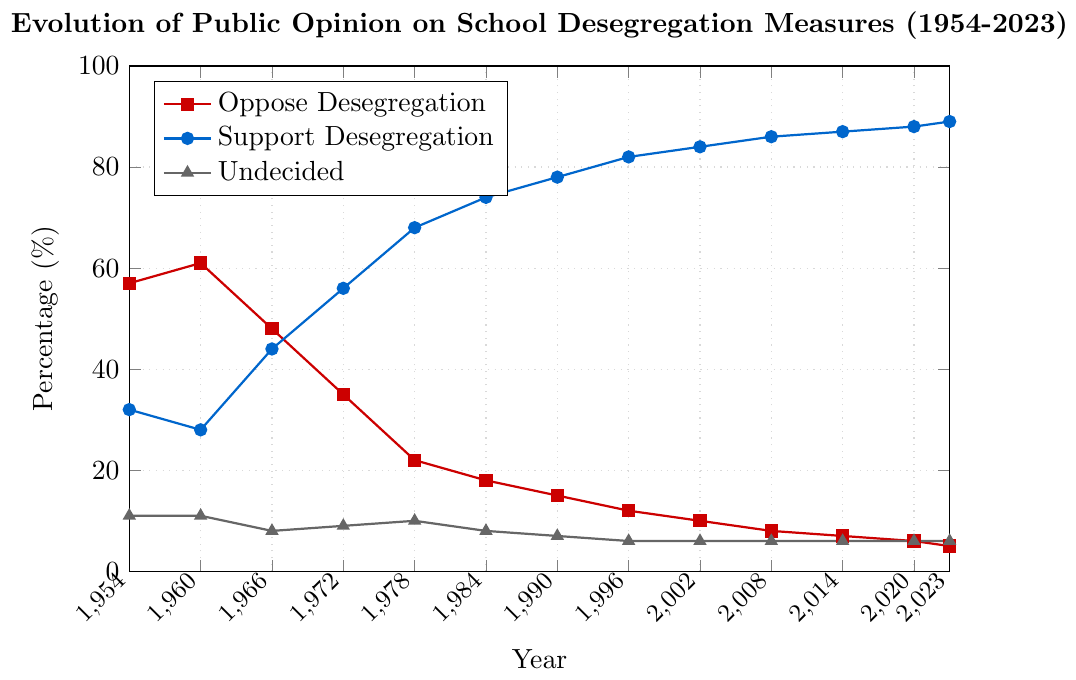What year had the highest percentage of opposition to desegregation? To find the year with the highest opposition, we need to look for the peak point in the "Oppose Desegregation" line, which happens in 1960 when the value is 61%.
Answer: 1960 What was the trend of support for desegregation from 1954 to 2023? Observing the line for "Support Desegregation", we see it starts at 32% in 1954 and steadily increases, reaching 89% in 2023, indicating a consistent upward trend in support over time.
Answer: Increasing How did the percentage of undecided people change from 1954 to 2023? The "Undecided" line starts at 11% in 1954 and remains relatively stable, with small fluctuations, ending at 6% in 2023.
Answer: Slightly Decreasing What is the difference in the percentage of support for desegregation between the years 1954 and 2023? The percentage of support for desegregation was 32% in 1954 and increased to 89% in 2023. The difference between these two percentages is 89% - 32% = 57%.
Answer: 57% In which year did the percentage supporting desegregation surpass the percentage opposing it? By comparing the two lines, we see that support surpasses opposition around 1966 when support increased to 44% and opposition dropped to 48%.
Answer: 1966 What year had the closest values between opposition and support percentages for desegregation? In 1966, the "Oppose Desegregation" percentage was 48% and the "Support Desegregation" percentage was 44%, making these values the closest over the years.
Answer: 1966 Was there any year when the percentage of undecided people was different from the overall trend of flattening? In the graph, the "Undecided" percentage stays mostly stable. However, in 1978, there was a minor increase to 10% and then it reverts back down to about 6%.
Answer: 1978 What is the cumulative decrease in opposition to desegregation from 1954 to 2023? Opposition to desegregation starts at 57% in 1954 and decreases to 5% in 2023. The cumulative decrease is 57% - 5% = 52%.
Answer: 52% How did public opinion shift between 1972 and 1978 regarding support for desegregation? Support for desegregation increased from 56% in 1972 to 68% in 1978, indicating a 12% positive shift.
Answer: Increase by 12% What visual pattern can be seen in the percentage of people opposing desegregation over time? The "Oppose Desegregation" line shows a decreasing trend from 1954 to 2023, starting high at 57% and falling steadily to 5%, visualized by a downward-sloping line.
Answer: Decreasing 